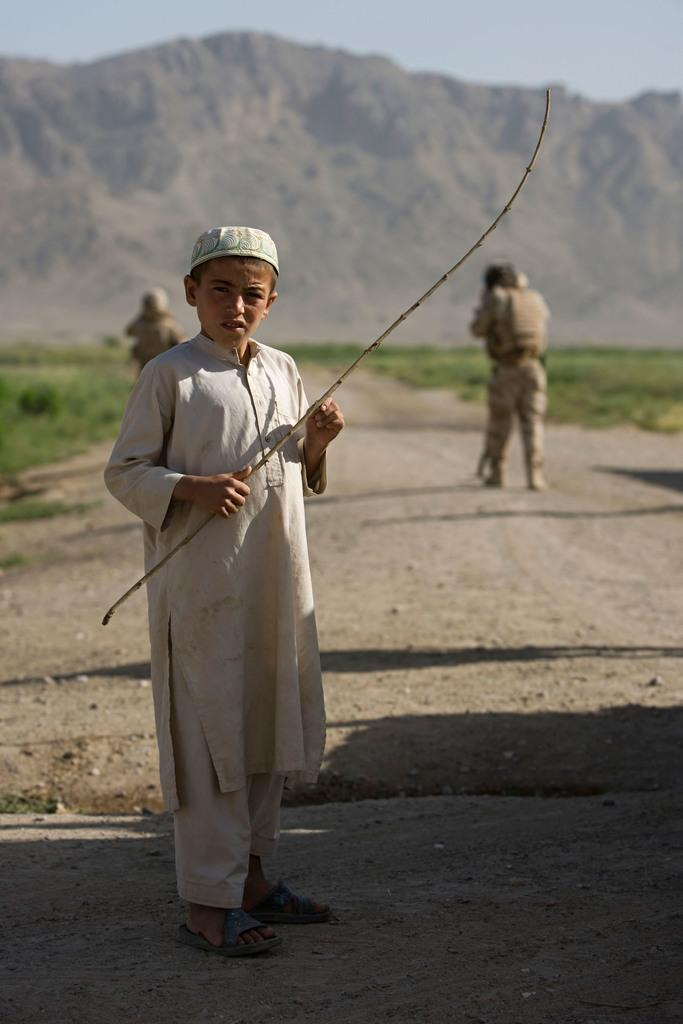Who is the main subject in the image? There is a boy in the image. What is the boy doing in the image? The boy is standing on a path. What is the boy holding in his hand? The boy is holding a stick in his hand. What can be seen in the background of the image? There are two people walking in the background of the image, and there is a mountain visible as well. What type of terrain is visible in the image? There is grassland visible in the image. What else can be seen in the sky in the image? The sky is visible in the image. What type of news can be heard coming from the pump in the image? There is no pump present in the image, so it is not possible to determine what news might be heard. 